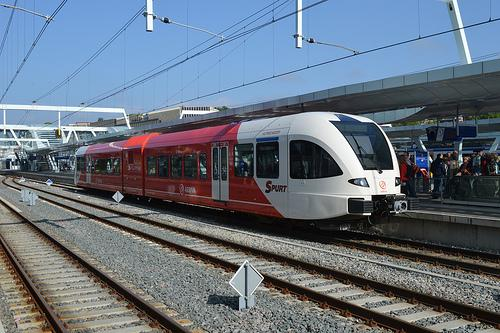Elaborate upon an interesting aspect of the train itself. The red and white train has a window in the front and a light on the front for better visibility on the tracks. Mention the type of environment visible in the background. There is a crystal clear blue sky in the background. Is there any text visible on the image? If yes, what does it say? Yes, there is red writing on the train, which says "spurt." Discuss the atmosphere or weather in the image based on visible clues. The season seems to be summer, with a clear blue sky indicating a sunny day. List three prominent objects that can be found in the image. A red and white train, rusty rail road tracks, and a silver diamond sign. Identify any human presence in the image and describe it. There are people waiting on the train platform near the red and white train. Describe the condition of the railroad tracks in the image. The railroad tracks appear to be rusty and have gravel in between them. Narrate an overview of the scene in the image. A red and white train is parked on the tracks at a station, with people waiting on the platform nearby. The blue sky and various signs are also visible in the image. What is the primary mode of transportation in the image? A red and white train on railroad tracks. How many train compartments can be seen in the image? There are at least two train compartments, an engine and a passenger car. Find a person wearing a yellow raincoat and holding an umbrella to battle the drizzling rain around the train station. The image does not depict any rain or people wearing specific clothing or carrying umbrellas. The instruction asks the viewer to search for details that don't exist in the image. Find the coordinates of the light on the train's front. X:352 Y:175 Width:17 Height:17 Describe the main object in the picture. A red and white train. Identify the color of the train Red and white List all object types included in the image. Train, tracks, sign, sky, doors, window, wall, people, light, railing, gravel, platform, engine, passenger car, windshield Can you spot a dog with a ball playing near the train tracks? The little dog is wagging its tail and chewing on a blue ball. No, it's not mentioned in the image. Read the text on the train. Spurt Identify the object at X:399 Y:208 Width:98 Height:98. A gray concrete wall What writing is present on the train? Red writing on a train What is the primary subject of this image? Red and white short train What is the function of the silver diamond sign? Train informational sign What is the color of the sky in this image? Blue Where is the large digital clock mounted on the platform, showing the time of the next train arrival for the waiting passengers? The image refers to people waiting on the train, a platform, and a sign, but there's no mention of a clock or timetable for train arrivals. The instruction tricks the viewer into looking for an object that is not depicted in the image. What are the people doing in the picture? Waiting on the train Locate the train's side window. X:287 Y:136 Width:61 Height:61 Determine the location of the silver sign. X:229 Y:260 Width:35 Height:35 Are there any people waiting for the train? Yes, people waiting on the train Notice the beautiful rainbow hovering above the train and appreciate how its colors reflect on the nearby buildings. The image only mentions a clear blue sky without any hints of a rainbow or any reflection of colors on buildings. The instruction is designed to make the viewer search for an object that is not present in the image. Pay attention to the graffiti art covering the gray concrete wall, featuring brilliant designs and colorful patterns. While there is a gray concrete wall mentioned in the image, there is no reference to any graffiti art or colorful designs. The instruction intends to mislead the viewer into searching for non-existent elements in the image. What is the condition of the train tracks? Rusty rail road tracks Estimate the current season in the picture. Summer How many sets of train tracks are there? 3 What type of sky is visible in the image? A crystal clear blue sky Describe the location where this photo was taken. In the city of Dayton 